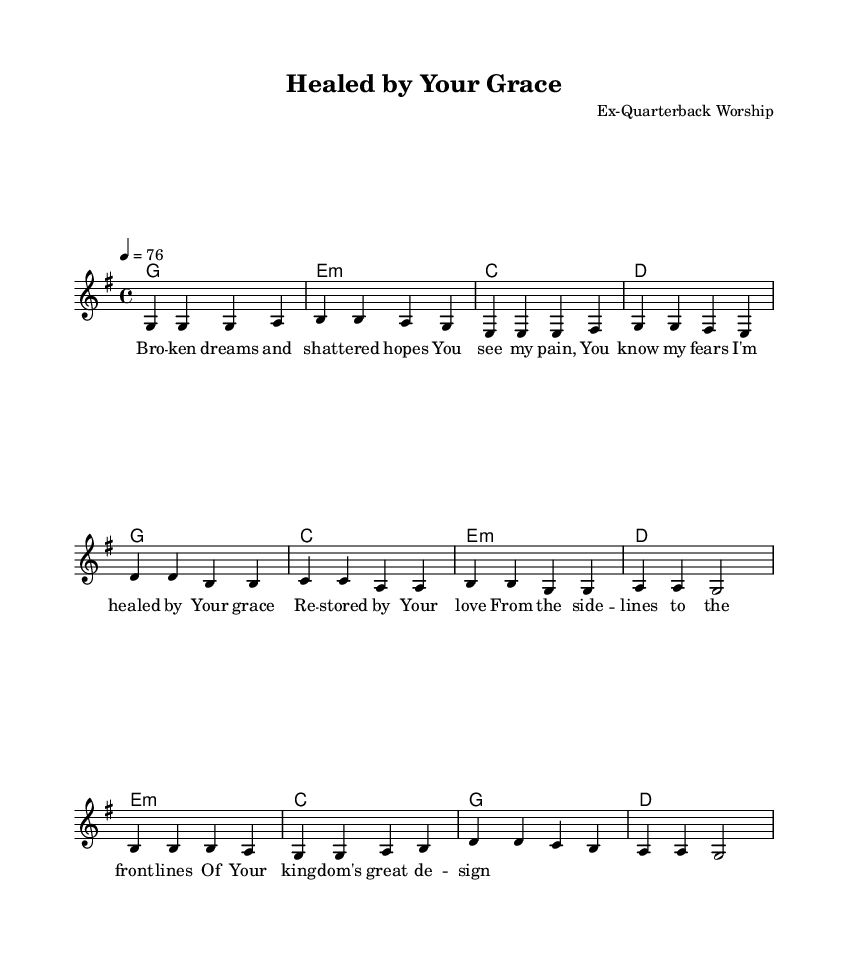What is the key signature of this music? The key signature is determined by the number of sharps or flats at the beginning of the staff. Here, there is one sharp (F#) indicating the key of G major.
Answer: G major What is the time signature of this song? The time signature appears at the beginning of the staff as a fraction. In this case, it is 4/4, meaning there are four beats in each measure.
Answer: 4/4 What is the tempo marking for the piece? The tempo marking is provided above the staff and states the beats per minute (BPM). Here, it is indicated as 4 = 76, meaning 76 quarter notes per minute.
Answer: 76 How many verses are in the song? Each section of the lyrics is labeled accordingly; the format shows the presence of one verse followed by a chorus and a bridge, indicating there is one verse in the song.
Answer: One What chord follows the verse in the chorus? To analyze the progression, look at the chords listed right after the verse section. The chord progression begins with G in the verse and transitions to C in the chorus.
Answer: C What themes are expressed in the lyrics? By examining the lyrics, they reflect themes of healing and restoration as expressed through phrases like "I'm healed by Your grace" and "restored by Your love." These highlight the overall emotional and religious themes.
Answer: Healing and restoration Which musical section contains the lyrics "From the sidelines to the front lines"? The lyrics are found in the bridge section, which differentiates itself from the verse and chorus and contains uplifting phrases central to the song’s message.
Answer: Bridge 